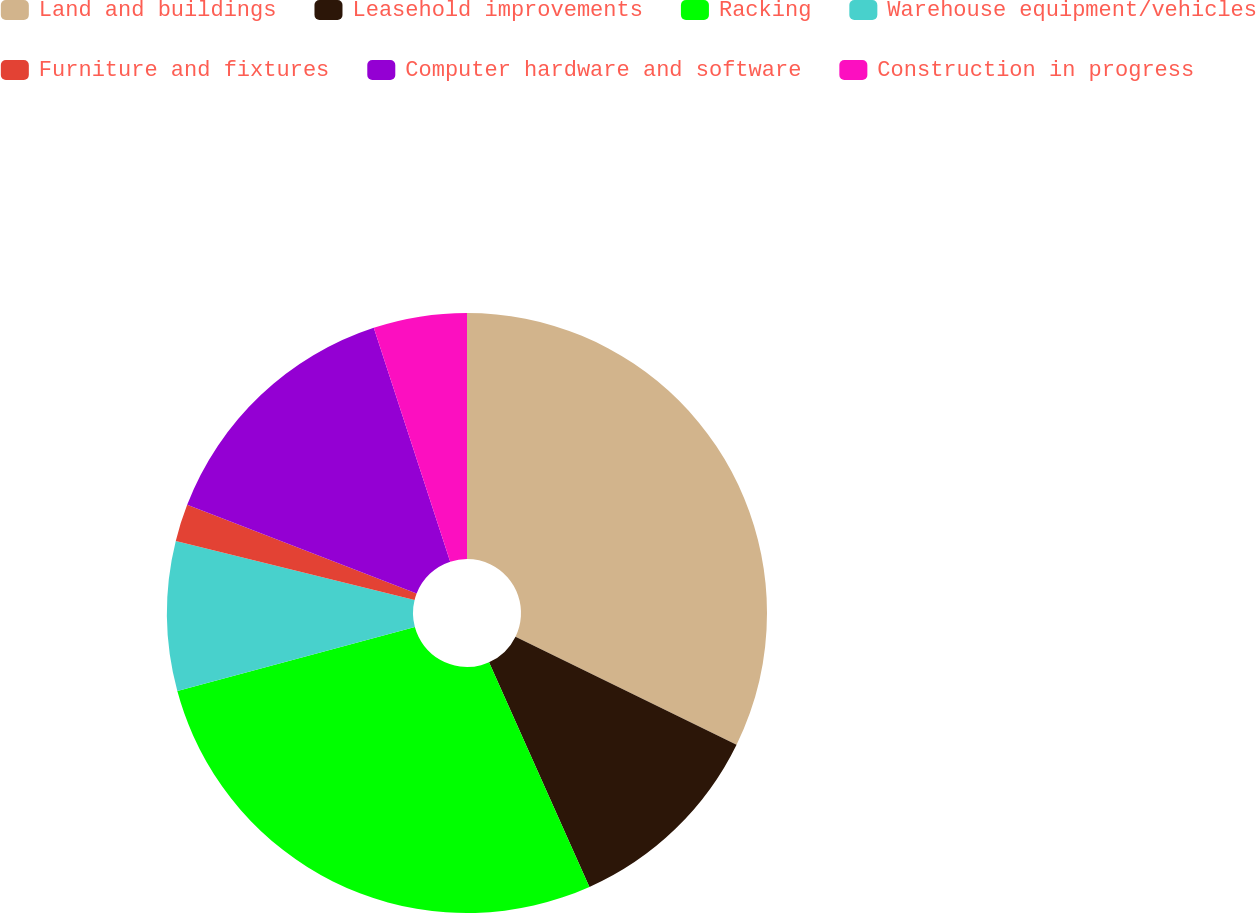Convert chart. <chart><loc_0><loc_0><loc_500><loc_500><pie_chart><fcel>Land and buildings<fcel>Leasehold improvements<fcel>Racking<fcel>Warehouse equipment/vehicles<fcel>Furniture and fixtures<fcel>Computer hardware and software<fcel>Construction in progress<nl><fcel>32.23%<fcel>11.08%<fcel>27.5%<fcel>8.05%<fcel>2.01%<fcel>14.1%<fcel>5.03%<nl></chart> 